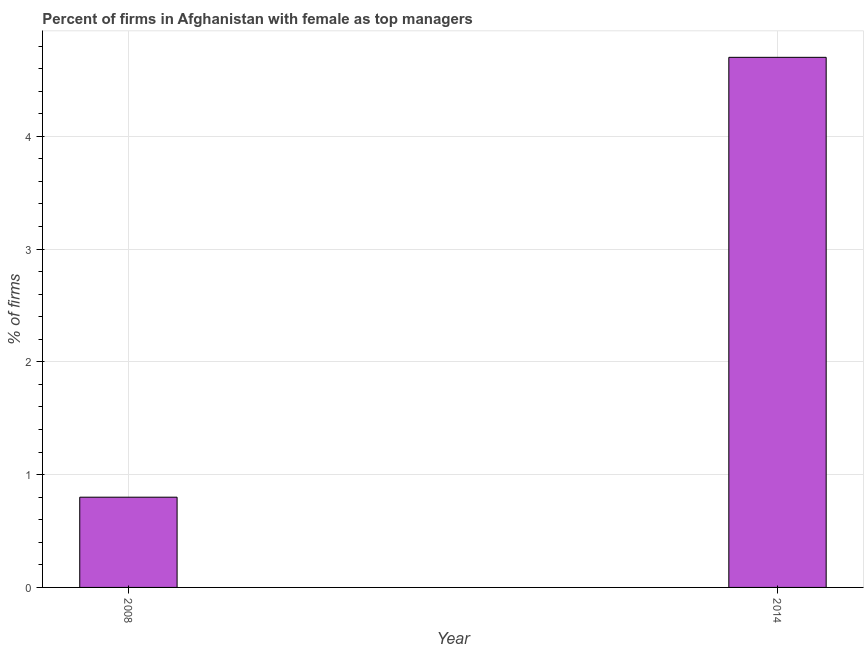Does the graph contain any zero values?
Your answer should be compact. No. Does the graph contain grids?
Ensure brevity in your answer.  Yes. What is the title of the graph?
Provide a short and direct response. Percent of firms in Afghanistan with female as top managers. What is the label or title of the Y-axis?
Ensure brevity in your answer.  % of firms. What is the percentage of firms with female as top manager in 2014?
Provide a short and direct response. 4.7. Across all years, what is the minimum percentage of firms with female as top manager?
Your answer should be very brief. 0.8. In which year was the percentage of firms with female as top manager minimum?
Provide a succinct answer. 2008. What is the difference between the percentage of firms with female as top manager in 2008 and 2014?
Ensure brevity in your answer.  -3.9. What is the average percentage of firms with female as top manager per year?
Make the answer very short. 2.75. What is the median percentage of firms with female as top manager?
Make the answer very short. 2.75. In how many years, is the percentage of firms with female as top manager greater than 1.8 %?
Give a very brief answer. 1. Do a majority of the years between 2014 and 2008 (inclusive) have percentage of firms with female as top manager greater than 3.4 %?
Offer a very short reply. No. What is the ratio of the percentage of firms with female as top manager in 2008 to that in 2014?
Provide a short and direct response. 0.17. Is the percentage of firms with female as top manager in 2008 less than that in 2014?
Your answer should be very brief. Yes. In how many years, is the percentage of firms with female as top manager greater than the average percentage of firms with female as top manager taken over all years?
Your answer should be compact. 1. Are all the bars in the graph horizontal?
Make the answer very short. No. Are the values on the major ticks of Y-axis written in scientific E-notation?
Keep it short and to the point. No. What is the % of firms of 2014?
Your answer should be very brief. 4.7. What is the ratio of the % of firms in 2008 to that in 2014?
Ensure brevity in your answer.  0.17. 